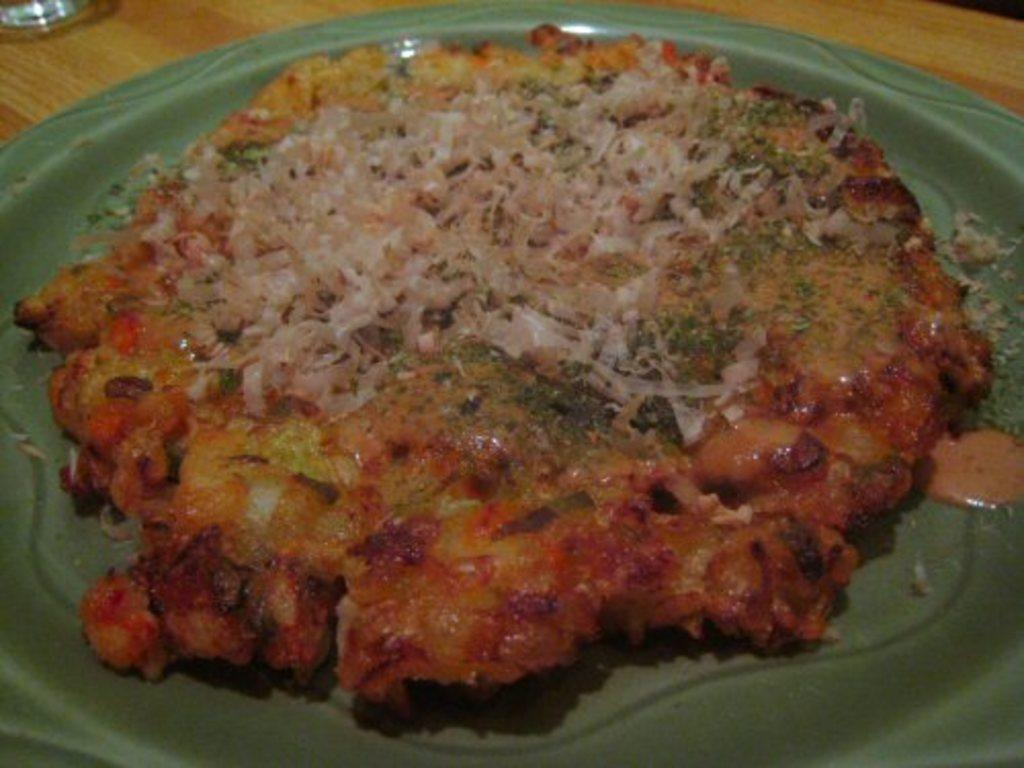What is on the plate in the image? There is food in the plate in the image. What can be seen in the background of the image? There is a table in the background of the image. What type of car is parked near the table in the image? There is no car present in the image; it only features a plate of food and a table in the background. 